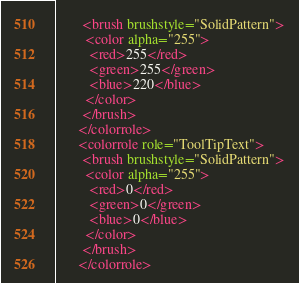<code> <loc_0><loc_0><loc_500><loc_500><_XML_>       <brush brushstyle="SolidPattern">
        <color alpha="255">
         <red>255</red>
         <green>255</green>
         <blue>220</blue>
        </color>
       </brush>
      </colorrole>
      <colorrole role="ToolTipText">
       <brush brushstyle="SolidPattern">
        <color alpha="255">
         <red>0</red>
         <green>0</green>
         <blue>0</blue>
        </color>
       </brush>
      </colorrole></code> 